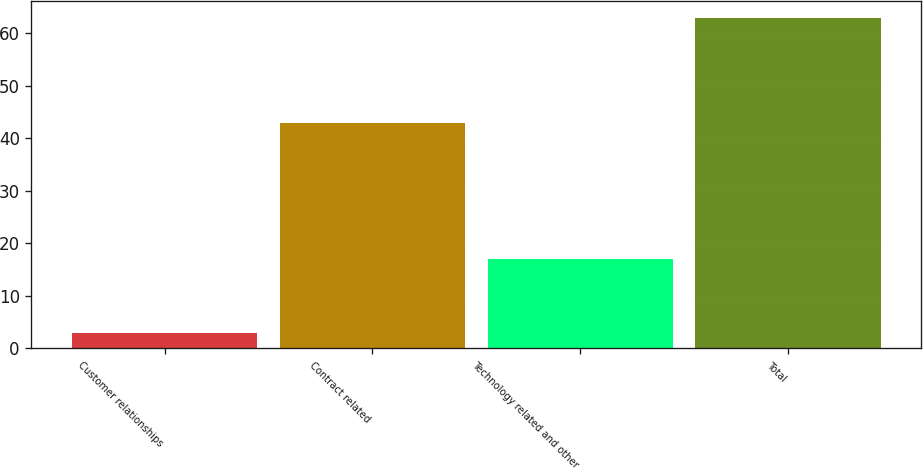Convert chart to OTSL. <chart><loc_0><loc_0><loc_500><loc_500><bar_chart><fcel>Customer relationships<fcel>Contract related<fcel>Technology related and other<fcel>Total<nl><fcel>3<fcel>43<fcel>17<fcel>63<nl></chart> 